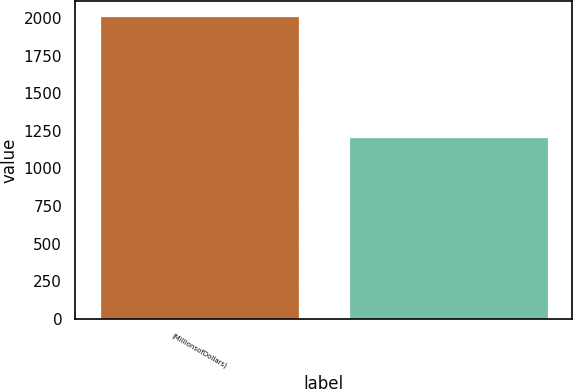<chart> <loc_0><loc_0><loc_500><loc_500><bar_chart><fcel>(MillionsofDollars)<fcel>Unnamed: 1<nl><fcel>2011<fcel>1211<nl></chart> 